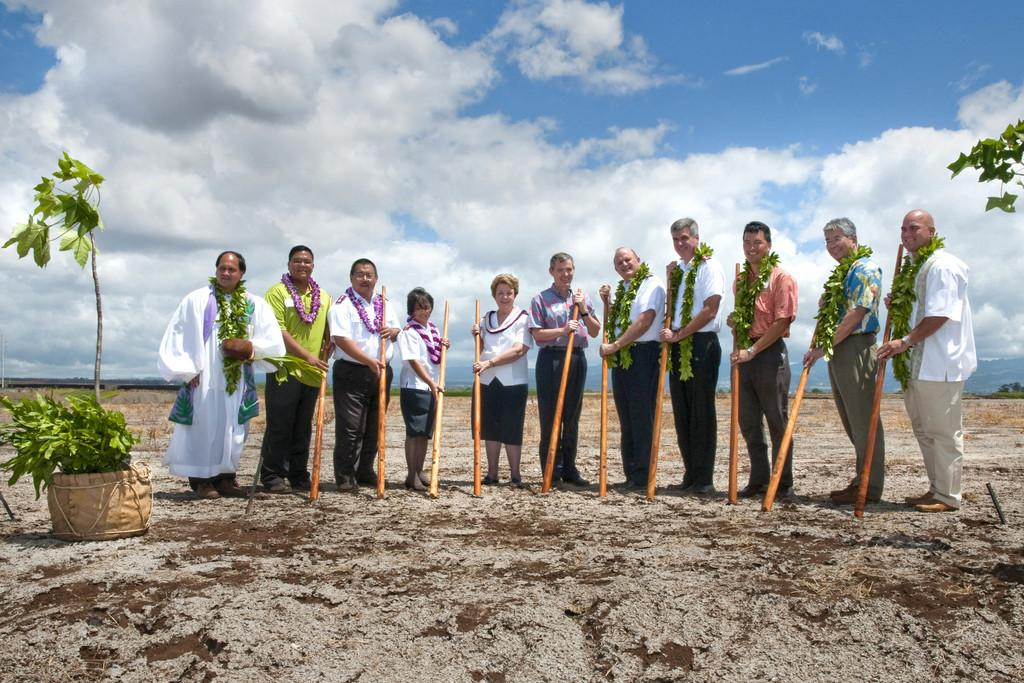How many people are present in the image? There are many people standing in the image. What are the people wearing? The people are wearing clothes. What are the people holding in their hands? The people are holding wooden sticks in their hands. What type of ground is visible in the image? The ground is soil. What other living organisms can be seen in the image? There are plants in the image. What is the weather like in the image? The sky is cloudy in the image. Can you describe any additional objects in the image? There is a leaf garland in the image. What type of destruction is caused by the tank in the image? There is no tank present in the image, so no destruction can be observed. Can you hear the drum in the image? There is no drum present in the image, so it cannot be heard. 